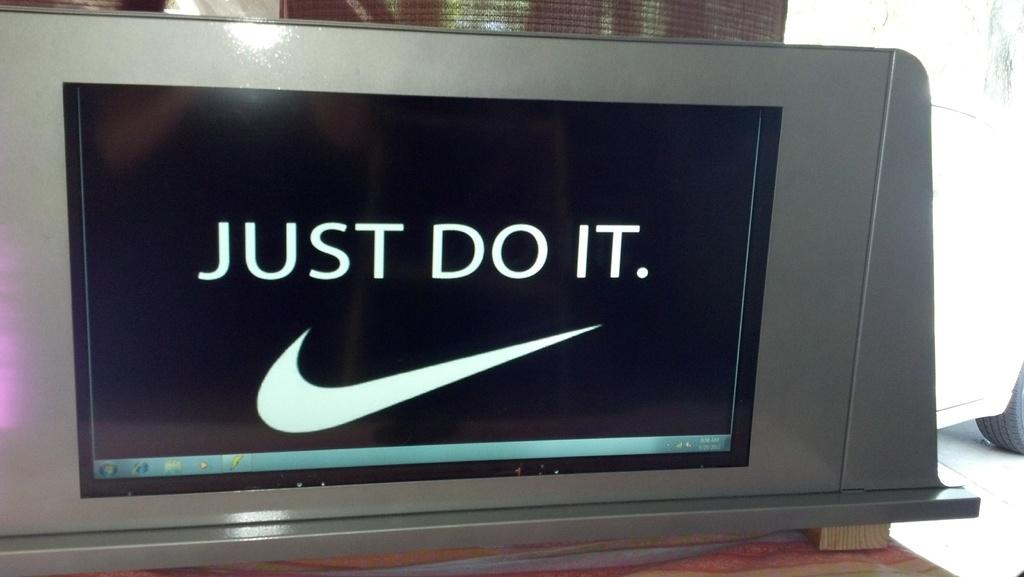<image>
Provide a brief description of the given image. A monitor shows the Nike tick and the words Just Do It 